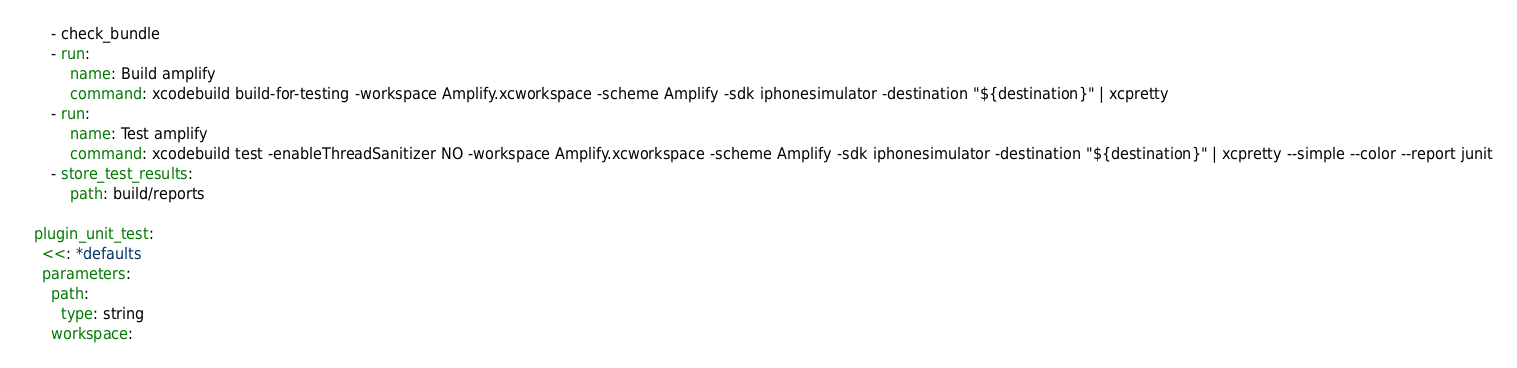Convert code to text. <code><loc_0><loc_0><loc_500><loc_500><_YAML_>      - check_bundle
      - run:
          name: Build amplify
          command: xcodebuild build-for-testing -workspace Amplify.xcworkspace -scheme Amplify -sdk iphonesimulator -destination "${destination}" | xcpretty
      - run:
          name: Test amplify
          command: xcodebuild test -enableThreadSanitizer NO -workspace Amplify.xcworkspace -scheme Amplify -sdk iphonesimulator -destination "${destination}" | xcpretty --simple --color --report junit
      - store_test_results:
          path: build/reports

  plugin_unit_test:
    <<: *defaults
    parameters:
      path:
        type: string
      workspace:</code> 